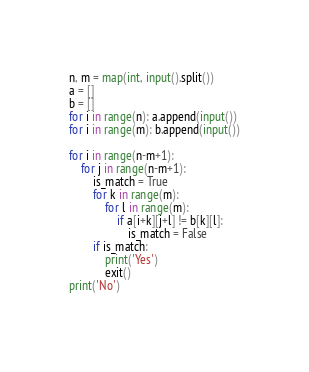Convert code to text. <code><loc_0><loc_0><loc_500><loc_500><_Python_>n, m = map(int, input().split())
a = []
b = []
for i in range(n): a.append(input())
for i in range(m): b.append(input())

for i in range(n-m+1):
    for j in range(n-m+1):
        is_match = True
        for k in range(m):
            for l in range(m):
                if a[i+k][j+l] != b[k][l]:
                    is_match = False
        if is_match:
            print('Yes')
            exit()
print('No')
            </code> 